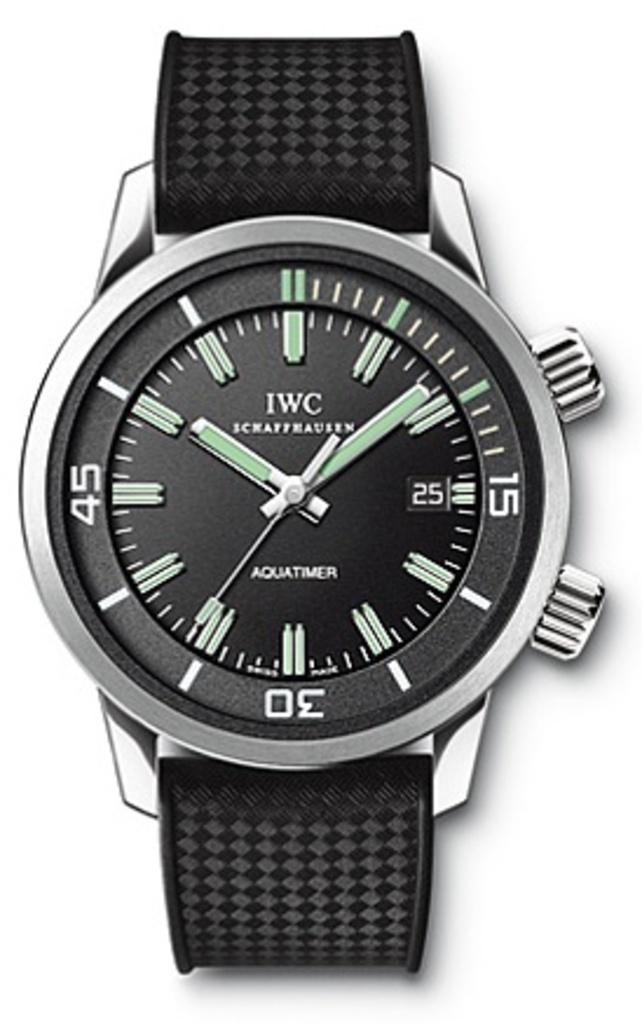<image>
Create a compact narrative representing the image presented. An IWC watch has a black fabric band with a diamond pattern. 